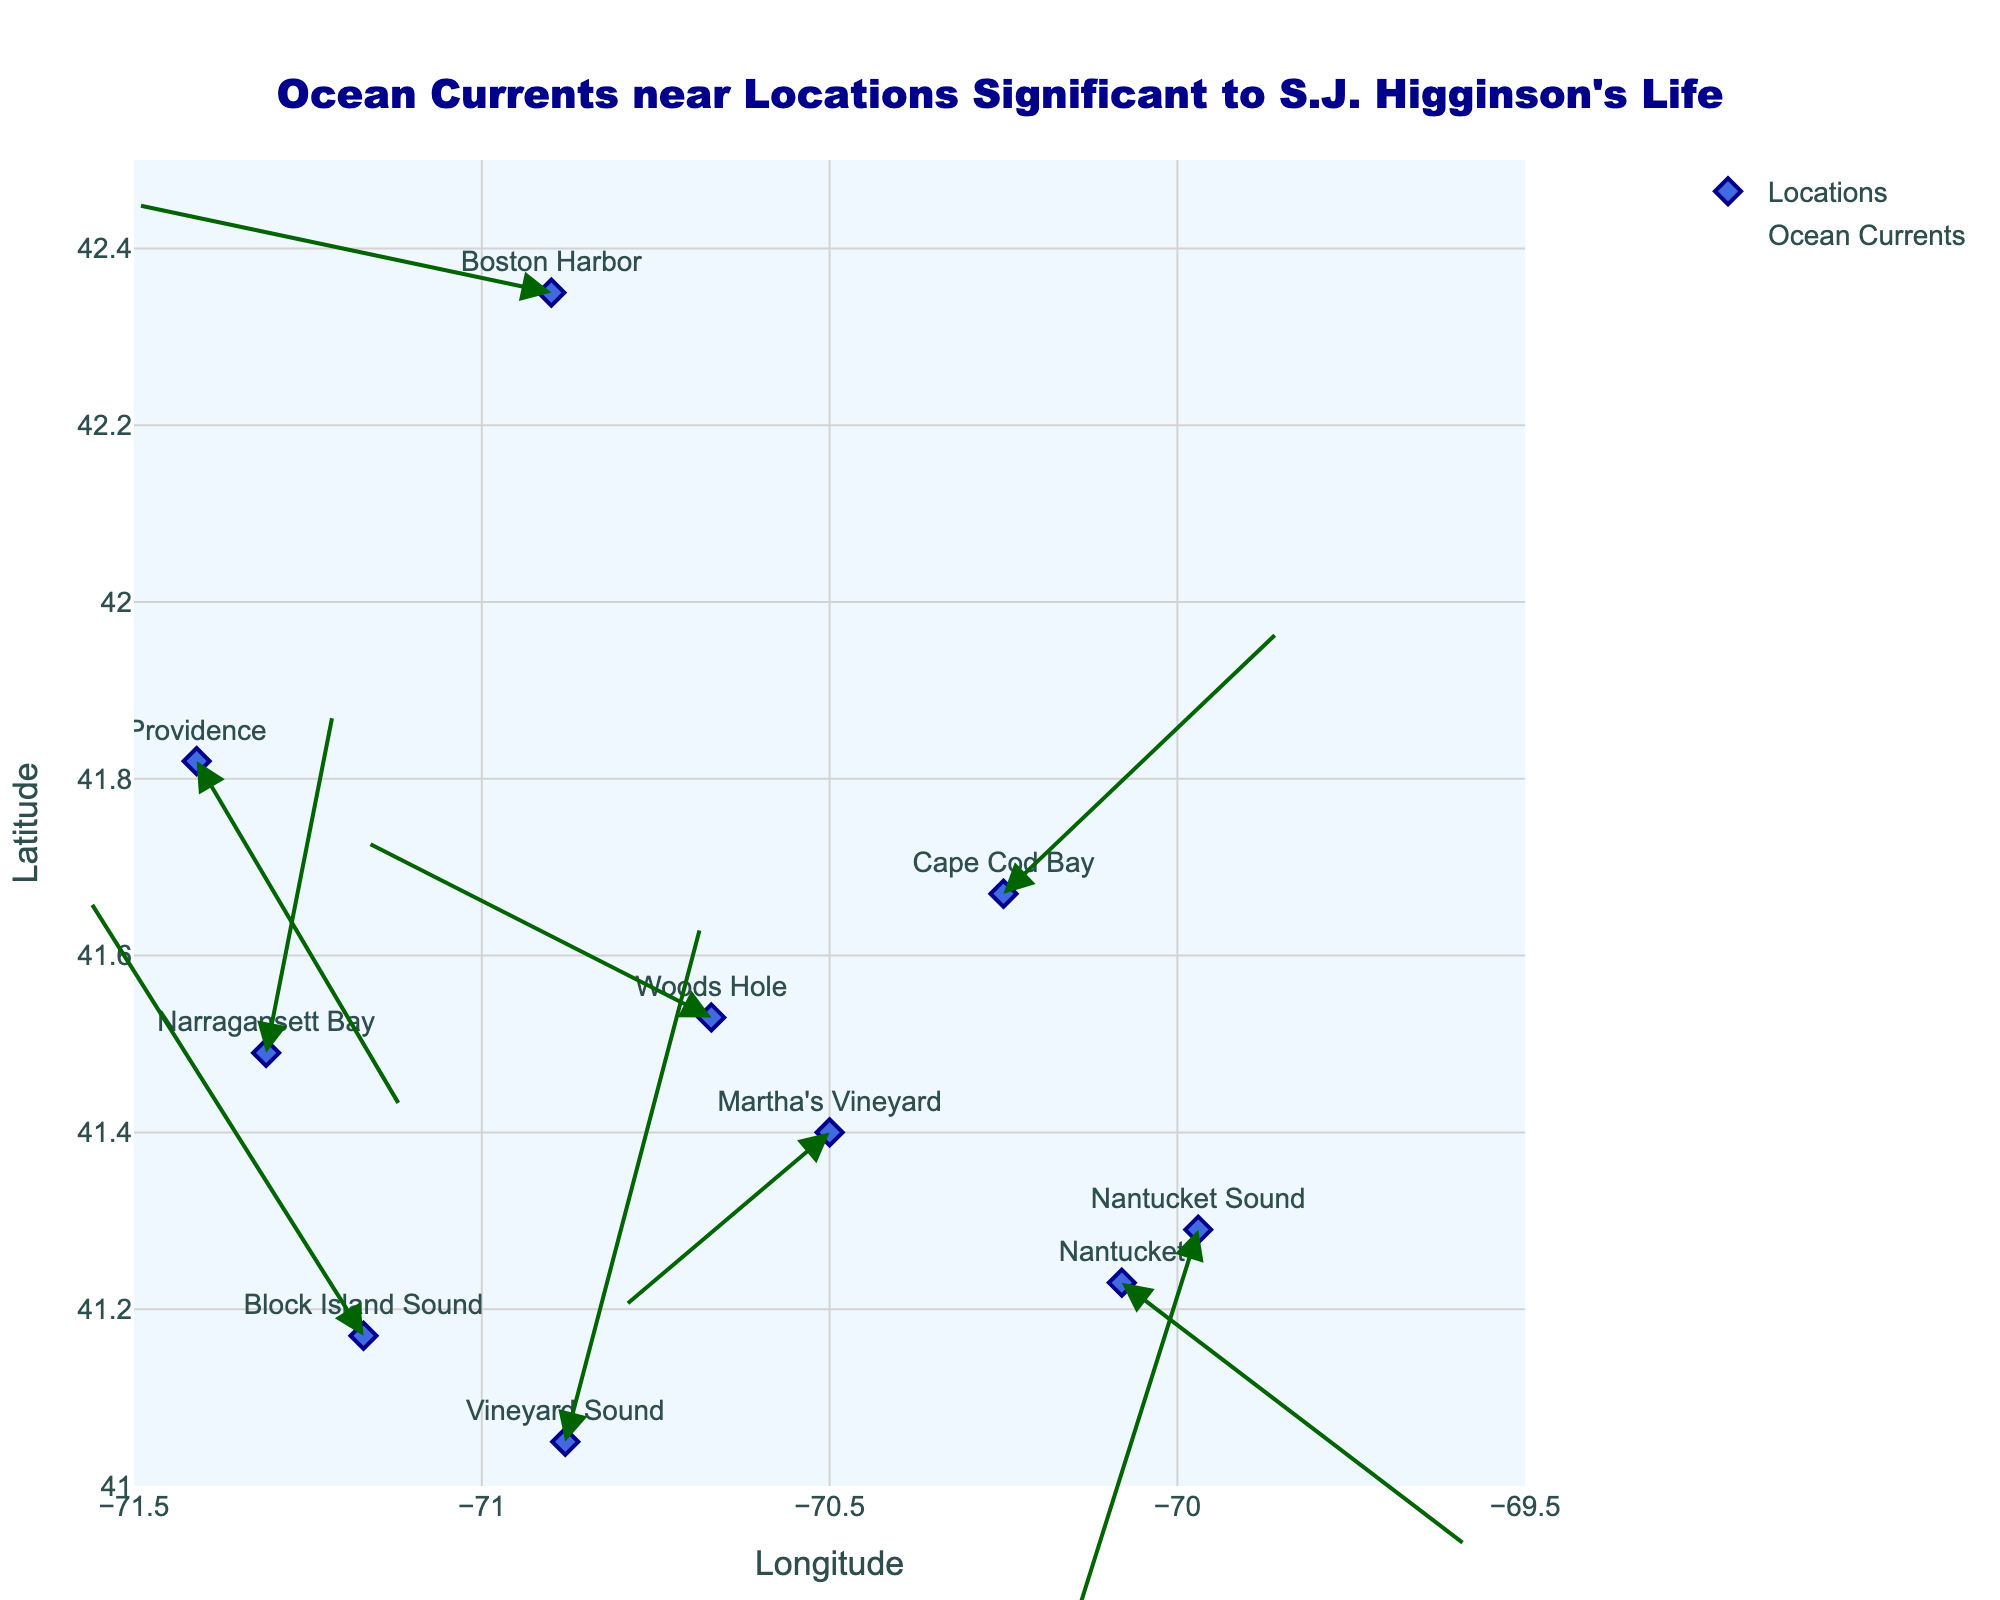What is the title of the figure? The title can be found at the top of the figure and is typically a descriptive phrase summarizing the content of the plot.
Answer: Ocean Currents near Locations Significant to S.J. Higginson's Life Which location shows the fastest current? To determine the fastest current, compare the lengths of the arrows representing the current speed at each location. The length is proportional to the magnitude of the sum of the u and v components of each current vector.
Answer: Vineyard Sound What are the longitude and latitude range covered in the plot? The longitude and latitude ranges can be found along the x and y axes respectively. The minimum and maximum values are visible at the edges of the axes.
Answer: Longitude: [-71.5, -69.5], Latitude: [41, 42.5] Compare the direction of currents at Nantucket Sound and Vineyard Sound. Which way do they flow? Look at the direction of the arrows for the currents at Nantucket Sound and Vineyard Sound. Nantucket Sound shows a vector pointing south-westward, while Vineyard Sound shows a vector pointing northward.
Answer: Nantucket Sound: south-westward, Vineyard Sound: northward How many locations significant to S.J. Higginson's life are represented in the plot? Count the number of markers (points) on the plot with associated text labels. Each marker represents a significant location.
Answer: 10 Which location has a current moving directly westward? Examine the direction of the arrows for each location; a westward movement corresponds to an arrow pointing directly left. Martha's Vineyard has an arrow pointing nearly directly west.
Answer: Martha's Vineyard What is the average speed of the currents at Woods Hole and Cape Cod Bay? Calculate the magnitudes of the vectors representing the currents using the components u and v: Speed at Woods Hole = sqrt((-0.5)^2 + (0.2)^2) ≈ 0.54, Speed at Cape Cod Bay = sqrt((0.4)^2 + (0.3)^2) ≈ 0.50. Then, find the average of these speeds: (0.54 + 0.50) / 2 ≈ 0.52.
Answer: Approximately 0.52 Which location has the current vector with the smallest horizontal component? The horizontal component of a current vector is given by the u value. Identify the location with the smallest u value by comparing all u values from the data.
Answer: Boston Harbor (u = -0.6) Determine the general direction of currents near Boston Harbor compared to Block Island Sound. Boston Harbor's current arrow points westward with a slight northward component, while Block Island Sound's arrow points north-westward. Therefore, Boston Harbor's currents are generally moving westward while Block Island Sound's move north-westward.
Answer: Boston Harbor: westward, Block Island Sound: north-westward 